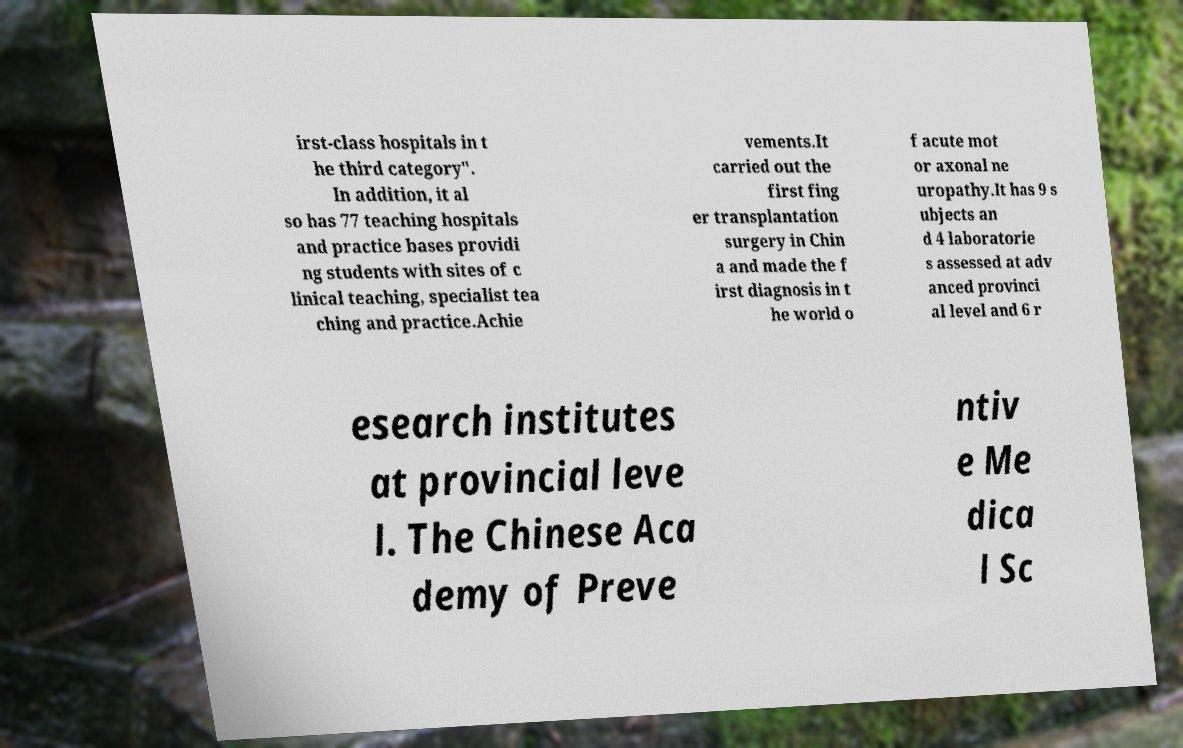Could you extract and type out the text from this image? irst-class hospitals in t he third category". In addition, it al so has 77 teaching hospitals and practice bases providi ng students with sites of c linical teaching, specialist tea ching and practice.Achie vements.It carried out the first fing er transplantation surgery in Chin a and made the f irst diagnosis in t he world o f acute mot or axonal ne uropathy.It has 9 s ubjects an d 4 laboratorie s assessed at adv anced provinci al level and 6 r esearch institutes at provincial leve l. The Chinese Aca demy of Preve ntiv e Me dica l Sc 